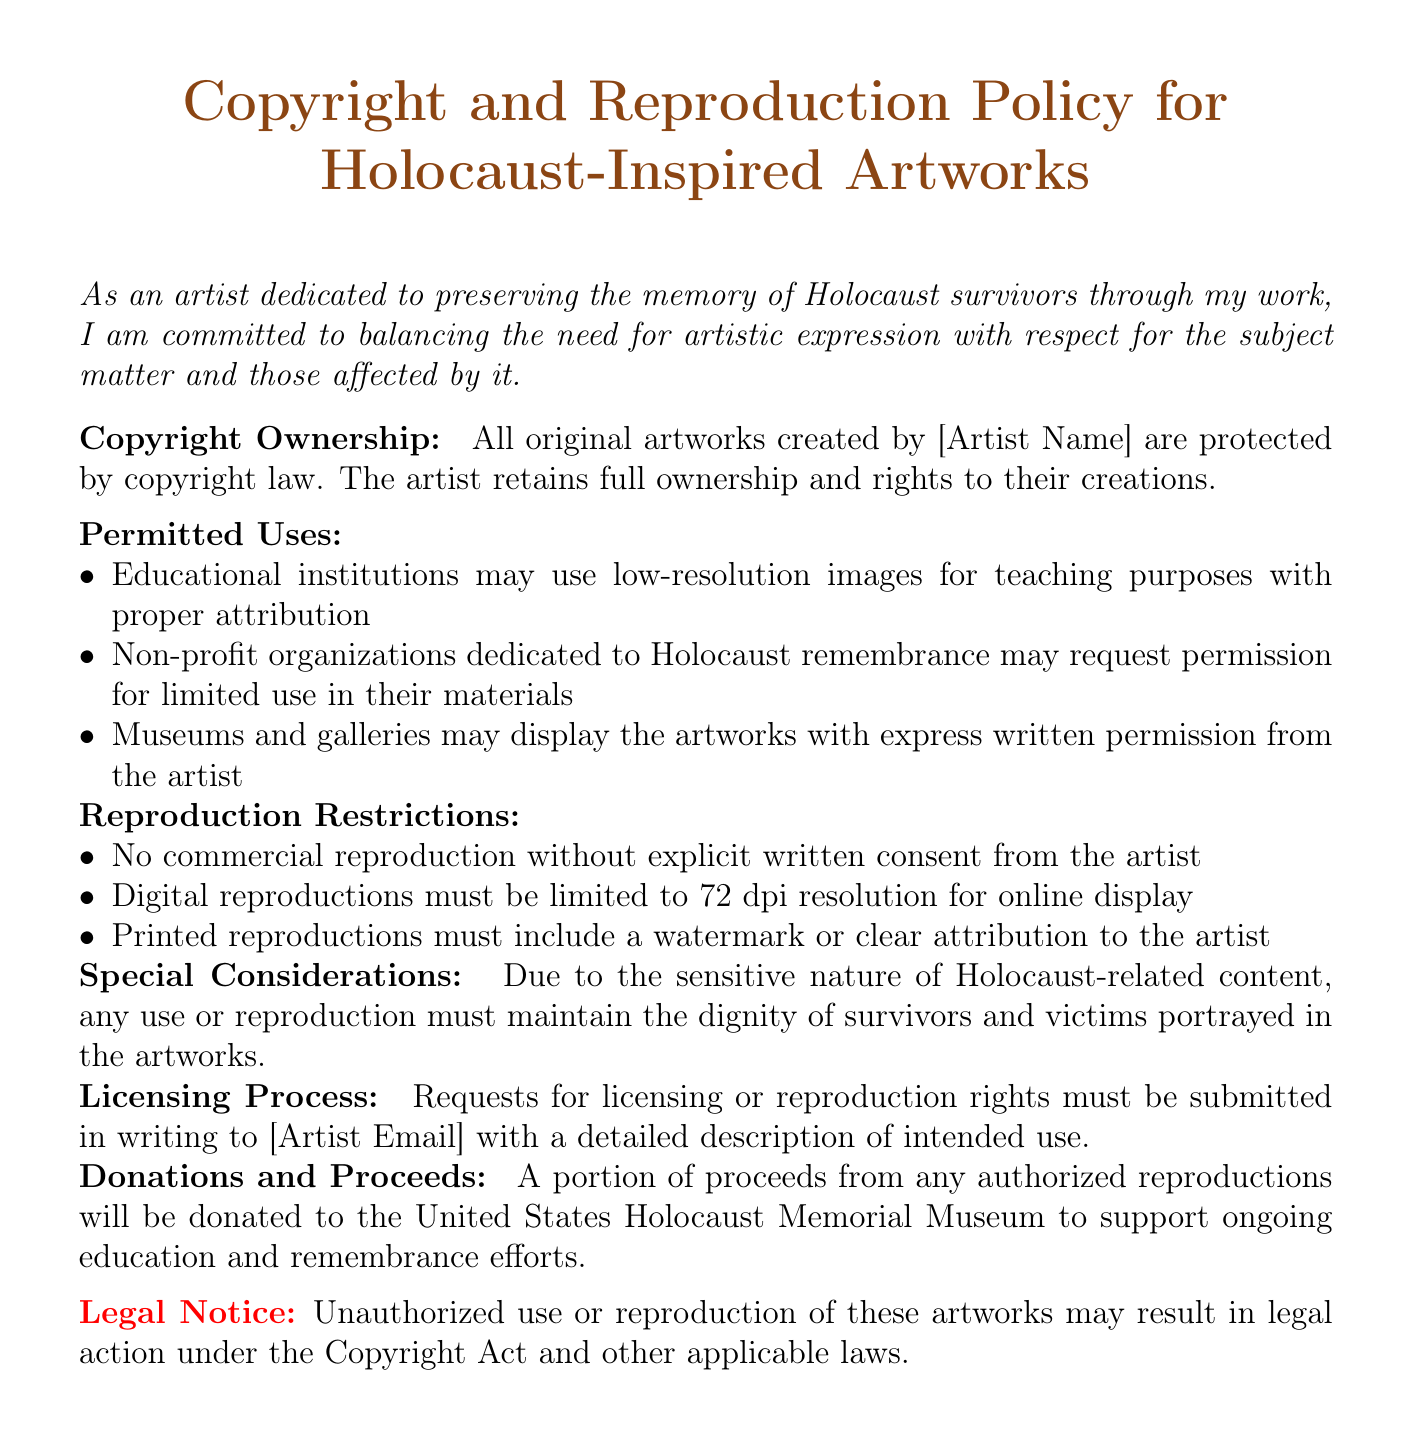What is the title of the document? The title of the document is stated prominently at the beginning.
Answer: Copyright and Reproduction Policy for Holocaust-Inspired Artworks Who owns the copyright of the artworks? The document mentions that the artist retains ownership rights over their creations.
Answer: [Artist Name] What is the maximum resolution for digital reproductions? The policy specifies a limitation on the resolution for digital displays.
Answer: 72 dpi What must printed reproductions include? The document outlines requirements for printed reproductions, specifying necessary elements.
Answer: A watermark or clear attribution to the artist What should educational institutions provide when using images? The document requires certain practices to be followed by educational institutions when using images.
Answer: Proper attribution What is the process to request licensing rights? The document describes how to initiate the licensing request process.
Answer: Submitted in writing to [Artist Email] What portion of proceeds from reproductions is donated? The policy mentions a specific charitable action related to proceeds from authorized reproductions.
Answer: A portion What is emphasized due to the sensitive nature of the content? The document highlights an important consideration that must be adhered to for respect and dignity.
Answer: Maintain the dignity of survivors and victims What is required for non-profit organizations to use artworks? The policy states a prerequisite for non-profit organizations wishing to utilize the artworks.
Answer: Request permission for limited use 